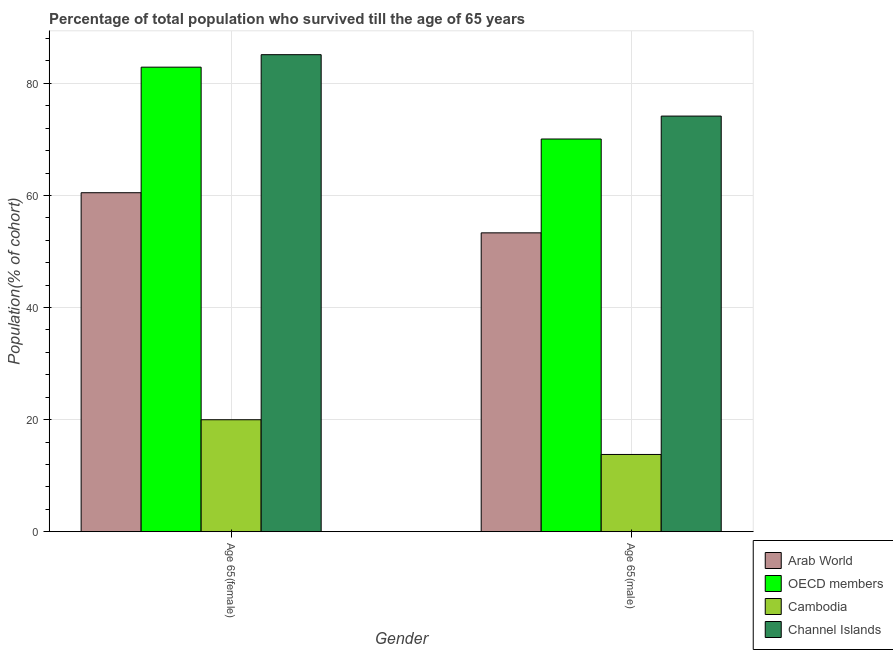Are the number of bars on each tick of the X-axis equal?
Offer a very short reply. Yes. What is the label of the 1st group of bars from the left?
Your answer should be very brief. Age 65(female). What is the percentage of male population who survived till age of 65 in OECD members?
Your answer should be compact. 70.07. Across all countries, what is the maximum percentage of male population who survived till age of 65?
Provide a short and direct response. 74.16. Across all countries, what is the minimum percentage of male population who survived till age of 65?
Your response must be concise. 13.78. In which country was the percentage of male population who survived till age of 65 maximum?
Your answer should be compact. Channel Islands. In which country was the percentage of female population who survived till age of 65 minimum?
Provide a succinct answer. Cambodia. What is the total percentage of male population who survived till age of 65 in the graph?
Your response must be concise. 211.34. What is the difference between the percentage of female population who survived till age of 65 in OECD members and that in Cambodia?
Provide a succinct answer. 62.91. What is the difference between the percentage of male population who survived till age of 65 in Channel Islands and the percentage of female population who survived till age of 65 in Cambodia?
Offer a terse response. 54.18. What is the average percentage of female population who survived till age of 65 per country?
Keep it short and to the point. 62.12. What is the difference between the percentage of male population who survived till age of 65 and percentage of female population who survived till age of 65 in OECD members?
Give a very brief answer. -12.82. What is the ratio of the percentage of male population who survived till age of 65 in Arab World to that in Channel Islands?
Provide a short and direct response. 0.72. What does the 1st bar from the right in Age 65(female) represents?
Keep it short and to the point. Channel Islands. How many countries are there in the graph?
Offer a very short reply. 4. Are the values on the major ticks of Y-axis written in scientific E-notation?
Provide a succinct answer. No. Does the graph contain grids?
Offer a very short reply. Yes. How many legend labels are there?
Provide a short and direct response. 4. How are the legend labels stacked?
Your answer should be very brief. Vertical. What is the title of the graph?
Offer a very short reply. Percentage of total population who survived till the age of 65 years. Does "China" appear as one of the legend labels in the graph?
Your answer should be compact. No. What is the label or title of the X-axis?
Your response must be concise. Gender. What is the label or title of the Y-axis?
Give a very brief answer. Population(% of cohort). What is the Population(% of cohort) in Arab World in Age 65(female)?
Ensure brevity in your answer.  60.49. What is the Population(% of cohort) in OECD members in Age 65(female)?
Ensure brevity in your answer.  82.89. What is the Population(% of cohort) in Cambodia in Age 65(female)?
Your answer should be very brief. 19.98. What is the Population(% of cohort) in Channel Islands in Age 65(female)?
Your answer should be very brief. 85.12. What is the Population(% of cohort) of Arab World in Age 65(male)?
Provide a short and direct response. 53.32. What is the Population(% of cohort) in OECD members in Age 65(male)?
Ensure brevity in your answer.  70.07. What is the Population(% of cohort) of Cambodia in Age 65(male)?
Make the answer very short. 13.78. What is the Population(% of cohort) of Channel Islands in Age 65(male)?
Ensure brevity in your answer.  74.16. Across all Gender, what is the maximum Population(% of cohort) of Arab World?
Ensure brevity in your answer.  60.49. Across all Gender, what is the maximum Population(% of cohort) of OECD members?
Your answer should be very brief. 82.89. Across all Gender, what is the maximum Population(% of cohort) in Cambodia?
Your response must be concise. 19.98. Across all Gender, what is the maximum Population(% of cohort) in Channel Islands?
Ensure brevity in your answer.  85.12. Across all Gender, what is the minimum Population(% of cohort) in Arab World?
Make the answer very short. 53.32. Across all Gender, what is the minimum Population(% of cohort) in OECD members?
Your answer should be compact. 70.07. Across all Gender, what is the minimum Population(% of cohort) of Cambodia?
Provide a short and direct response. 13.78. Across all Gender, what is the minimum Population(% of cohort) in Channel Islands?
Your answer should be compact. 74.16. What is the total Population(% of cohort) in Arab World in the graph?
Provide a short and direct response. 113.81. What is the total Population(% of cohort) in OECD members in the graph?
Provide a succinct answer. 152.96. What is the total Population(% of cohort) in Cambodia in the graph?
Ensure brevity in your answer.  33.76. What is the total Population(% of cohort) of Channel Islands in the graph?
Make the answer very short. 159.28. What is the difference between the Population(% of cohort) of Arab World in Age 65(female) and that in Age 65(male)?
Make the answer very short. 7.16. What is the difference between the Population(% of cohort) of OECD members in Age 65(female) and that in Age 65(male)?
Offer a terse response. 12.82. What is the difference between the Population(% of cohort) in Cambodia in Age 65(female) and that in Age 65(male)?
Keep it short and to the point. 6.19. What is the difference between the Population(% of cohort) of Channel Islands in Age 65(female) and that in Age 65(male)?
Ensure brevity in your answer.  10.96. What is the difference between the Population(% of cohort) of Arab World in Age 65(female) and the Population(% of cohort) of OECD members in Age 65(male)?
Give a very brief answer. -9.58. What is the difference between the Population(% of cohort) in Arab World in Age 65(female) and the Population(% of cohort) in Cambodia in Age 65(male)?
Keep it short and to the point. 46.7. What is the difference between the Population(% of cohort) in Arab World in Age 65(female) and the Population(% of cohort) in Channel Islands in Age 65(male)?
Provide a short and direct response. -13.67. What is the difference between the Population(% of cohort) of OECD members in Age 65(female) and the Population(% of cohort) of Cambodia in Age 65(male)?
Provide a succinct answer. 69.11. What is the difference between the Population(% of cohort) of OECD members in Age 65(female) and the Population(% of cohort) of Channel Islands in Age 65(male)?
Provide a short and direct response. 8.73. What is the difference between the Population(% of cohort) of Cambodia in Age 65(female) and the Population(% of cohort) of Channel Islands in Age 65(male)?
Your answer should be very brief. -54.18. What is the average Population(% of cohort) in Arab World per Gender?
Ensure brevity in your answer.  56.91. What is the average Population(% of cohort) in OECD members per Gender?
Make the answer very short. 76.48. What is the average Population(% of cohort) in Cambodia per Gender?
Ensure brevity in your answer.  16.88. What is the average Population(% of cohort) in Channel Islands per Gender?
Your answer should be compact. 79.64. What is the difference between the Population(% of cohort) of Arab World and Population(% of cohort) of OECD members in Age 65(female)?
Provide a succinct answer. -22.4. What is the difference between the Population(% of cohort) in Arab World and Population(% of cohort) in Cambodia in Age 65(female)?
Offer a terse response. 40.51. What is the difference between the Population(% of cohort) in Arab World and Population(% of cohort) in Channel Islands in Age 65(female)?
Your answer should be very brief. -24.63. What is the difference between the Population(% of cohort) of OECD members and Population(% of cohort) of Cambodia in Age 65(female)?
Offer a very short reply. 62.91. What is the difference between the Population(% of cohort) in OECD members and Population(% of cohort) in Channel Islands in Age 65(female)?
Your answer should be compact. -2.23. What is the difference between the Population(% of cohort) in Cambodia and Population(% of cohort) in Channel Islands in Age 65(female)?
Offer a very short reply. -65.14. What is the difference between the Population(% of cohort) of Arab World and Population(% of cohort) of OECD members in Age 65(male)?
Your response must be concise. -16.75. What is the difference between the Population(% of cohort) of Arab World and Population(% of cohort) of Cambodia in Age 65(male)?
Provide a short and direct response. 39.54. What is the difference between the Population(% of cohort) of Arab World and Population(% of cohort) of Channel Islands in Age 65(male)?
Give a very brief answer. -20.84. What is the difference between the Population(% of cohort) in OECD members and Population(% of cohort) in Cambodia in Age 65(male)?
Make the answer very short. 56.29. What is the difference between the Population(% of cohort) in OECD members and Population(% of cohort) in Channel Islands in Age 65(male)?
Provide a succinct answer. -4.09. What is the difference between the Population(% of cohort) in Cambodia and Population(% of cohort) in Channel Islands in Age 65(male)?
Keep it short and to the point. -60.38. What is the ratio of the Population(% of cohort) in Arab World in Age 65(female) to that in Age 65(male)?
Your answer should be very brief. 1.13. What is the ratio of the Population(% of cohort) of OECD members in Age 65(female) to that in Age 65(male)?
Ensure brevity in your answer.  1.18. What is the ratio of the Population(% of cohort) in Cambodia in Age 65(female) to that in Age 65(male)?
Keep it short and to the point. 1.45. What is the ratio of the Population(% of cohort) of Channel Islands in Age 65(female) to that in Age 65(male)?
Provide a succinct answer. 1.15. What is the difference between the highest and the second highest Population(% of cohort) in Arab World?
Offer a terse response. 7.16. What is the difference between the highest and the second highest Population(% of cohort) of OECD members?
Ensure brevity in your answer.  12.82. What is the difference between the highest and the second highest Population(% of cohort) of Cambodia?
Keep it short and to the point. 6.19. What is the difference between the highest and the second highest Population(% of cohort) of Channel Islands?
Offer a terse response. 10.96. What is the difference between the highest and the lowest Population(% of cohort) of Arab World?
Make the answer very short. 7.16. What is the difference between the highest and the lowest Population(% of cohort) in OECD members?
Offer a very short reply. 12.82. What is the difference between the highest and the lowest Population(% of cohort) of Cambodia?
Make the answer very short. 6.19. What is the difference between the highest and the lowest Population(% of cohort) in Channel Islands?
Keep it short and to the point. 10.96. 